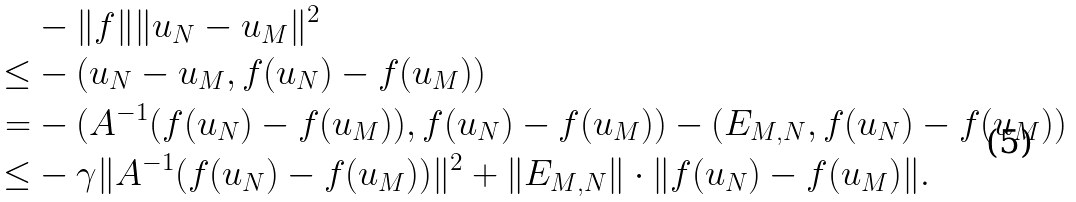Convert formula to latex. <formula><loc_0><loc_0><loc_500><loc_500>& - \| f \| \| u _ { N } - u _ { M } \| ^ { 2 } \\ \leq & - ( u _ { N } - u _ { M } , f ( u _ { N } ) - f ( u _ { M } ) ) \\ = & - ( A ^ { - 1 } ( f ( u _ { N } ) - f ( u _ { M } ) ) , f ( u _ { N } ) - f ( u _ { M } ) ) - ( E _ { M , N } , f ( u _ { N } ) - f ( u _ { M } ) ) \\ \leq & - \gamma \| A ^ { - 1 } ( f ( u _ { N } ) - f ( u _ { M } ) ) \| ^ { 2 } + \| E _ { M , N } \| \cdot \| f ( u _ { N } ) - f ( u _ { M } ) \| .</formula> 